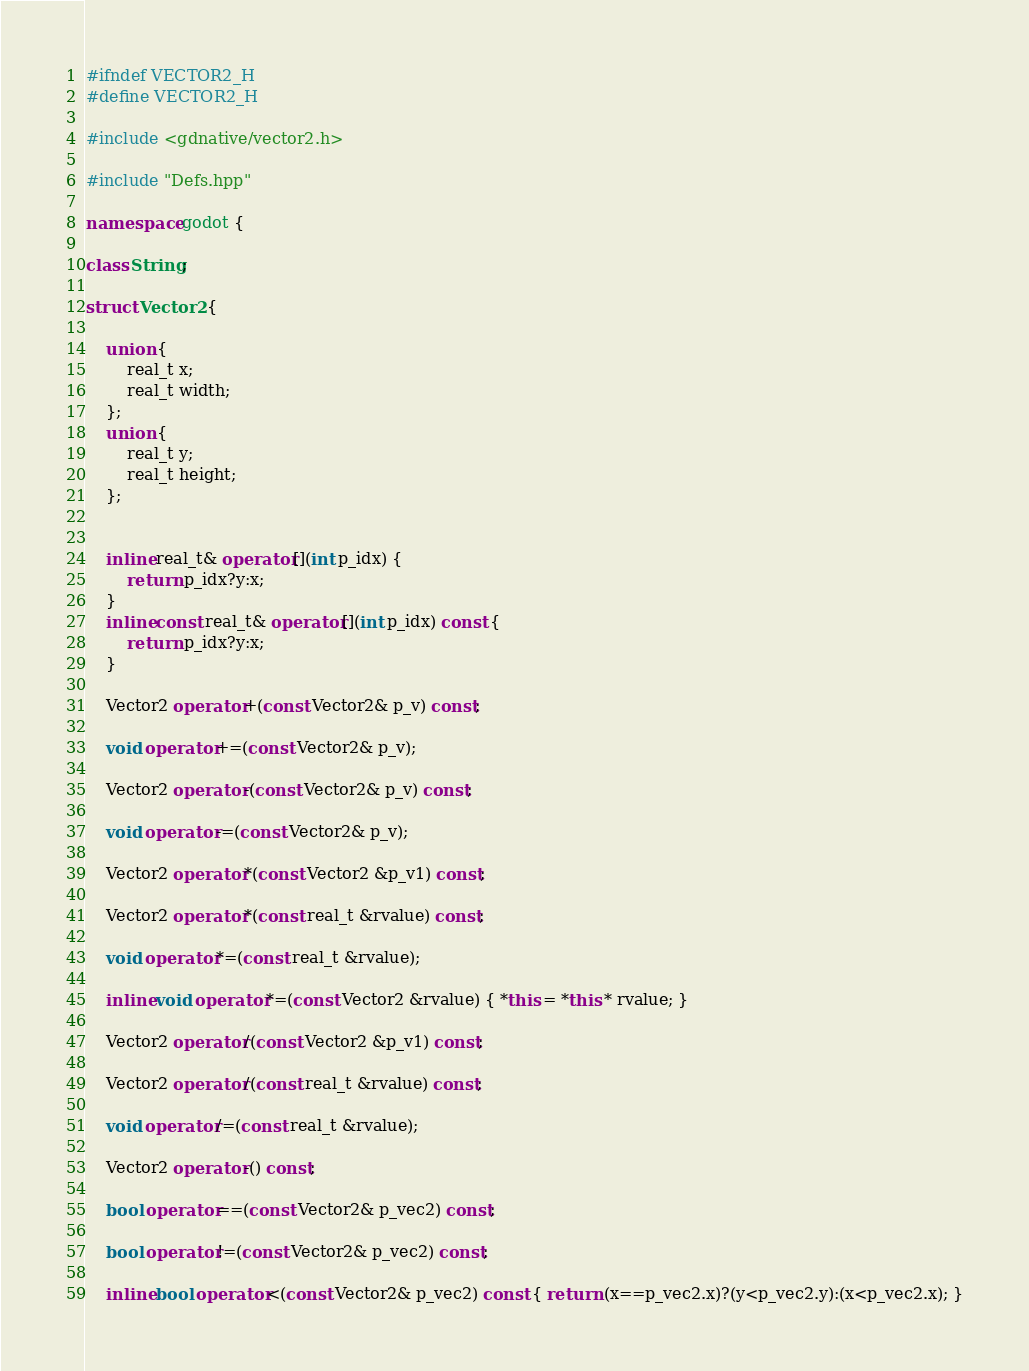<code> <loc_0><loc_0><loc_500><loc_500><_C++_>#ifndef VECTOR2_H
#define VECTOR2_H

#include <gdnative/vector2.h>

#include "Defs.hpp"

namespace godot {

class String;

struct Vector2 {

	union {
		real_t x;
		real_t width;
	};
	union {
		real_t y;
		real_t height;
	};


	inline real_t& operator[](int p_idx) {
		return p_idx?y:x;
	}
	inline const real_t& operator[](int p_idx) const {
		return p_idx?y:x;
	}

	Vector2 operator+(const Vector2& p_v) const;

	void operator+=(const Vector2& p_v);

	Vector2 operator-(const Vector2& p_v) const;

	void operator-=(const Vector2& p_v);

	Vector2 operator*(const Vector2 &p_v1) const;

	Vector2 operator*(const real_t &rvalue) const;

	void operator*=(const real_t &rvalue);

	inline void operator*=(const Vector2 &rvalue) { *this = *this * rvalue; }

	Vector2 operator/(const Vector2 &p_v1) const;

	Vector2 operator/(const real_t &rvalue) const;

	void operator/=(const real_t &rvalue);

	Vector2 operator-() const;

	bool operator==(const Vector2& p_vec2) const;

	bool operator!=(const Vector2& p_vec2) const;

	inline bool operator<(const Vector2& p_vec2) const { return (x==p_vec2.x)?(y<p_vec2.y):(x<p_vec2.x); }</code> 